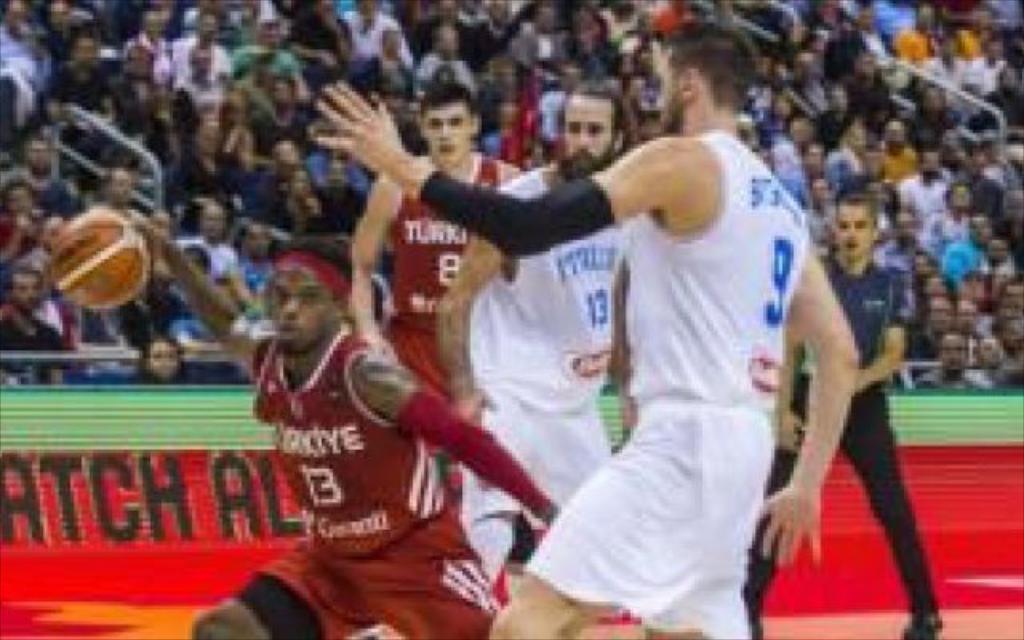Please provide a concise description of this image. In the picture we can see some players are playing a basketball and in the background, we can see audience sitting and watching them. 